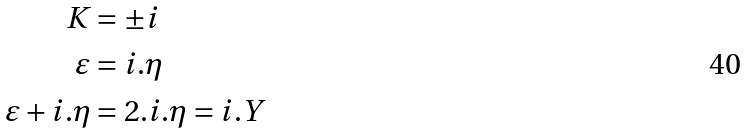Convert formula to latex. <formula><loc_0><loc_0><loc_500><loc_500>K & = \pm i \\ \varepsilon & = i . \eta \\ \varepsilon + i . \eta & = 2 . i . \eta = i . Y</formula> 